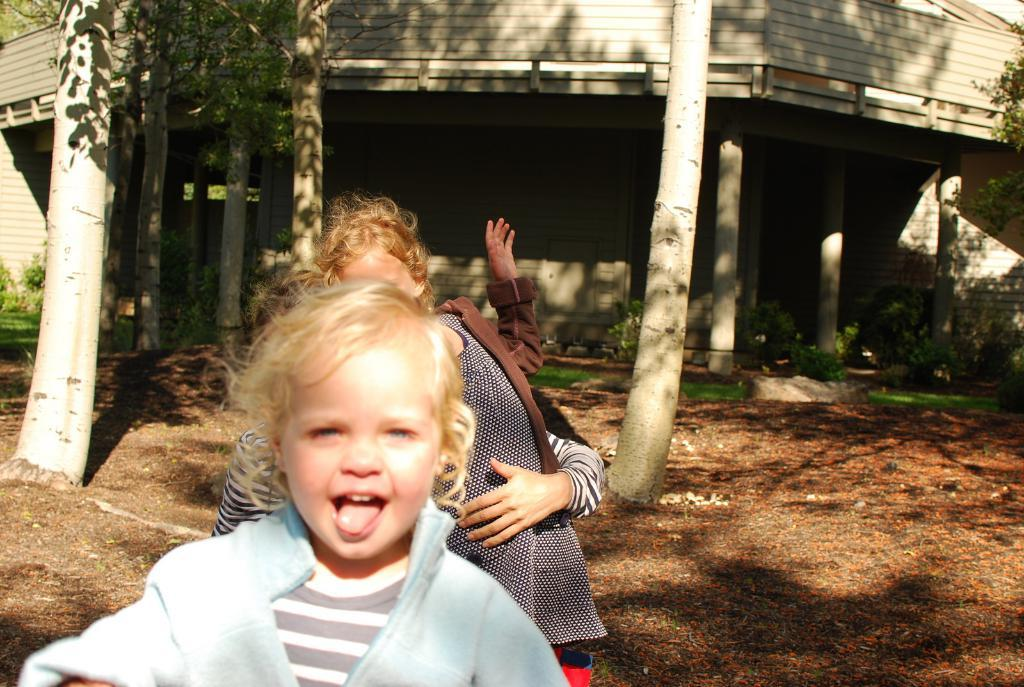What can be seen in the image? There are girls standing in the image. Where are the girls standing? The girls are standing on the ground. What can be seen in the background of the image? There are trees and a building in the background of the image. What type of sweater is the girl wearing in the image? There is no information about the girls wearing sweaters in the image, so we cannot answer this question. 